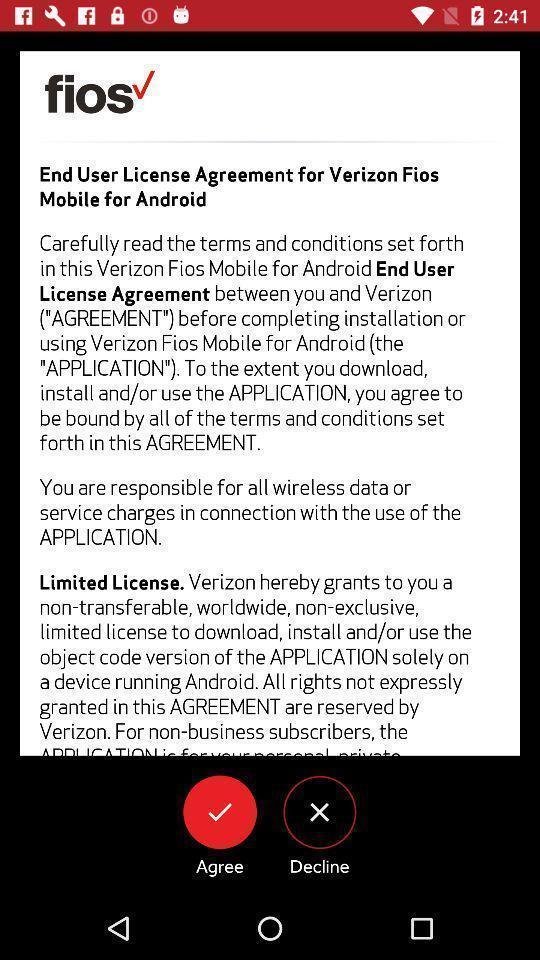Explain the elements present in this screenshot. Screen shows about agreement to accept. 